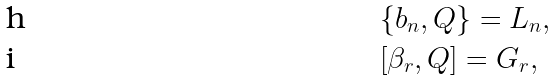<formula> <loc_0><loc_0><loc_500><loc_500>& \{ b _ { n } , Q \} = L _ { n } , \\ & [ \beta _ { r } , Q ] = G _ { r } ,</formula> 